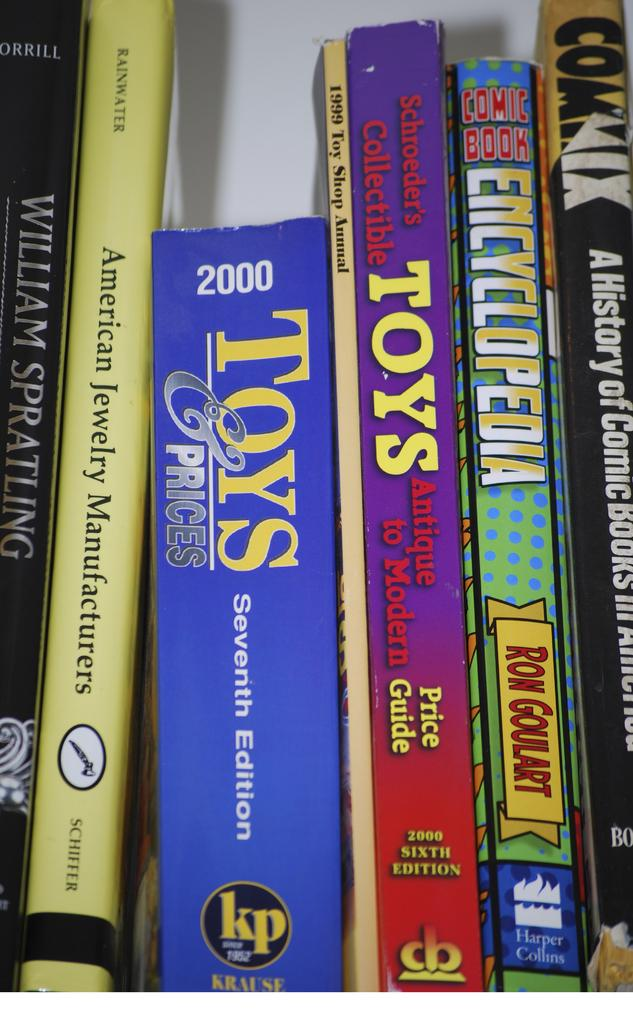<image>
Create a compact narrative representing the image presented. On a shelf of books of toys and comics, is also a book on jewelry manufacturing. 